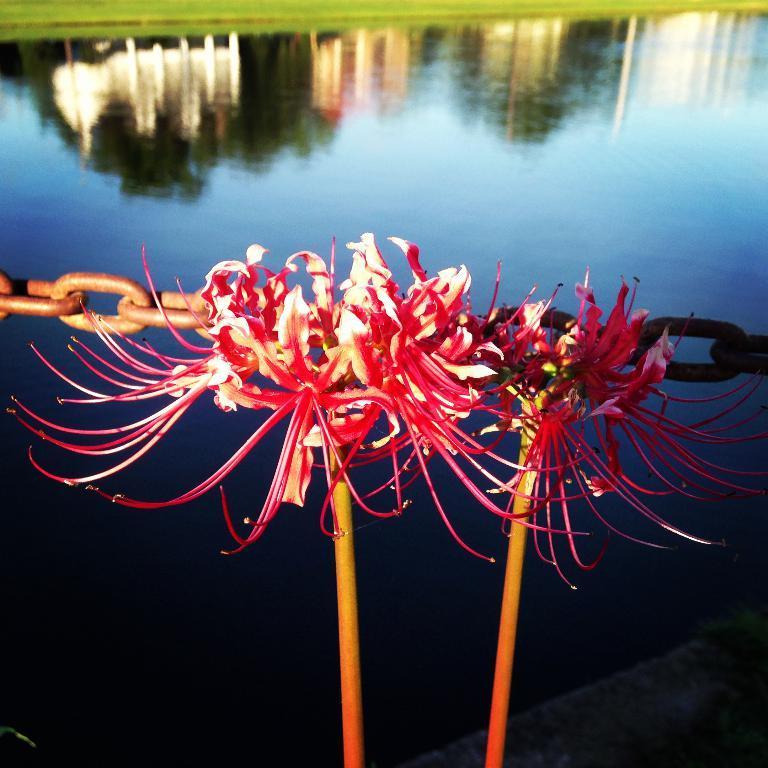Describe this image in one or two sentences. In this image I can see flowering plants, metal chain, water and grass. This image is taken may be near the lake. 